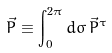<formula> <loc_0><loc_0><loc_500><loc_500>\vec { P } \equiv \int _ { 0 } ^ { 2 \pi } d \sigma \, \vec { P } ^ { \tau }</formula> 